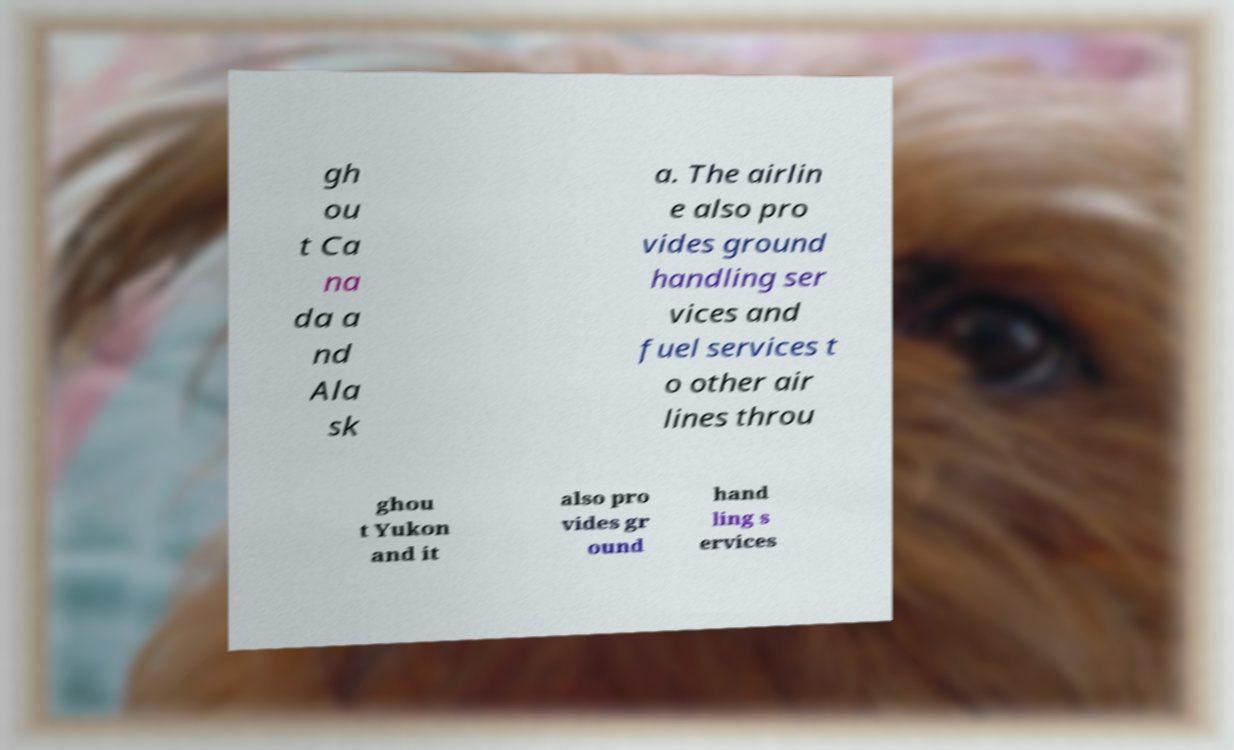Could you extract and type out the text from this image? gh ou t Ca na da a nd Ala sk a. The airlin e also pro vides ground handling ser vices and fuel services t o other air lines throu ghou t Yukon and it also pro vides gr ound hand ling s ervices 